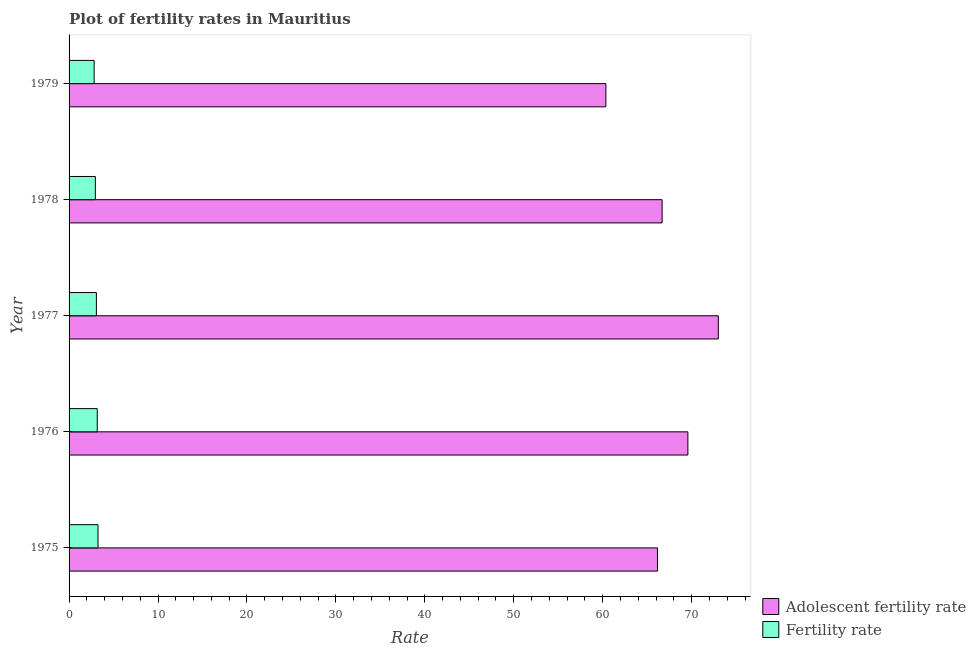How many bars are there on the 2nd tick from the bottom?
Keep it short and to the point. 2. What is the label of the 1st group of bars from the top?
Your answer should be compact. 1979. In how many cases, is the number of bars for a given year not equal to the number of legend labels?
Provide a succinct answer. 0. What is the adolescent fertility rate in 1977?
Your answer should be very brief. 73. Across all years, what is the maximum fertility rate?
Make the answer very short. 3.25. Across all years, what is the minimum fertility rate?
Offer a very short reply. 2.82. In which year was the fertility rate minimum?
Provide a succinct answer. 1979. What is the total adolescent fertility rate in the graph?
Keep it short and to the point. 335.78. What is the difference between the fertility rate in 1975 and that in 1979?
Make the answer very short. 0.44. What is the difference between the adolescent fertility rate in 1979 and the fertility rate in 1977?
Make the answer very short. 57.29. What is the average fertility rate per year?
Your response must be concise. 3.05. In the year 1976, what is the difference between the adolescent fertility rate and fertility rate?
Make the answer very short. 66.41. In how many years, is the fertility rate greater than 44 ?
Provide a short and direct response. 0. What is the ratio of the adolescent fertility rate in 1975 to that in 1977?
Your response must be concise. 0.91. What is the difference between the highest and the second highest adolescent fertility rate?
Keep it short and to the point. 3.42. What is the difference between the highest and the lowest fertility rate?
Give a very brief answer. 0.44. In how many years, is the fertility rate greater than the average fertility rate taken over all years?
Give a very brief answer. 3. What does the 1st bar from the top in 1978 represents?
Your answer should be very brief. Fertility rate. What does the 1st bar from the bottom in 1976 represents?
Give a very brief answer. Adolescent fertility rate. How many bars are there?
Provide a succinct answer. 10. What is the difference between two consecutive major ticks on the X-axis?
Give a very brief answer. 10. Are the values on the major ticks of X-axis written in scientific E-notation?
Your response must be concise. No. Does the graph contain any zero values?
Your answer should be very brief. No. Does the graph contain grids?
Your response must be concise. No. Where does the legend appear in the graph?
Ensure brevity in your answer.  Bottom right. What is the title of the graph?
Offer a very short reply. Plot of fertility rates in Mauritius. Does "Mobile cellular" appear as one of the legend labels in the graph?
Ensure brevity in your answer.  No. What is the label or title of the X-axis?
Your answer should be very brief. Rate. What is the Rate in Adolescent fertility rate in 1975?
Your answer should be compact. 66.16. What is the Rate of Fertility rate in 1975?
Offer a very short reply. 3.25. What is the Rate in Adolescent fertility rate in 1976?
Make the answer very short. 69.58. What is the Rate in Fertility rate in 1976?
Your response must be concise. 3.17. What is the Rate in Adolescent fertility rate in 1977?
Keep it short and to the point. 73. What is the Rate in Fertility rate in 1977?
Your answer should be very brief. 3.07. What is the Rate in Adolescent fertility rate in 1978?
Ensure brevity in your answer.  66.68. What is the Rate in Fertility rate in 1978?
Your response must be concise. 2.95. What is the Rate in Adolescent fertility rate in 1979?
Your answer should be very brief. 60.36. What is the Rate of Fertility rate in 1979?
Offer a very short reply. 2.82. Across all years, what is the maximum Rate of Adolescent fertility rate?
Offer a very short reply. 73. Across all years, what is the maximum Rate in Fertility rate?
Your response must be concise. 3.25. Across all years, what is the minimum Rate in Adolescent fertility rate?
Ensure brevity in your answer.  60.36. Across all years, what is the minimum Rate of Fertility rate?
Give a very brief answer. 2.82. What is the total Rate of Adolescent fertility rate in the graph?
Your answer should be very brief. 335.78. What is the total Rate of Fertility rate in the graph?
Your response must be concise. 15.27. What is the difference between the Rate in Adolescent fertility rate in 1975 and that in 1976?
Ensure brevity in your answer.  -3.42. What is the difference between the Rate of Fertility rate in 1975 and that in 1976?
Make the answer very short. 0.09. What is the difference between the Rate of Adolescent fertility rate in 1975 and that in 1977?
Provide a succinct answer. -6.84. What is the difference between the Rate in Fertility rate in 1975 and that in 1977?
Make the answer very short. 0.18. What is the difference between the Rate in Adolescent fertility rate in 1975 and that in 1978?
Provide a short and direct response. -0.52. What is the difference between the Rate in Fertility rate in 1975 and that in 1978?
Give a very brief answer. 0.3. What is the difference between the Rate in Adolescent fertility rate in 1975 and that in 1979?
Offer a terse response. 5.8. What is the difference between the Rate of Fertility rate in 1975 and that in 1979?
Your response must be concise. 0.44. What is the difference between the Rate in Adolescent fertility rate in 1976 and that in 1977?
Offer a terse response. -3.42. What is the difference between the Rate of Fertility rate in 1976 and that in 1977?
Give a very brief answer. 0.1. What is the difference between the Rate in Adolescent fertility rate in 1976 and that in 1978?
Keep it short and to the point. 2.9. What is the difference between the Rate of Fertility rate in 1976 and that in 1978?
Your answer should be very brief. 0.21. What is the difference between the Rate of Adolescent fertility rate in 1976 and that in 1979?
Make the answer very short. 9.22. What is the difference between the Rate in Fertility rate in 1976 and that in 1979?
Offer a terse response. 0.35. What is the difference between the Rate of Adolescent fertility rate in 1977 and that in 1978?
Offer a terse response. 6.32. What is the difference between the Rate of Fertility rate in 1977 and that in 1978?
Offer a terse response. 0.12. What is the difference between the Rate of Adolescent fertility rate in 1977 and that in 1979?
Offer a terse response. 12.64. What is the difference between the Rate in Fertility rate in 1977 and that in 1979?
Offer a terse response. 0.25. What is the difference between the Rate of Adolescent fertility rate in 1978 and that in 1979?
Make the answer very short. 6.32. What is the difference between the Rate in Fertility rate in 1978 and that in 1979?
Ensure brevity in your answer.  0.14. What is the difference between the Rate in Adolescent fertility rate in 1975 and the Rate in Fertility rate in 1976?
Your response must be concise. 62.99. What is the difference between the Rate in Adolescent fertility rate in 1975 and the Rate in Fertility rate in 1977?
Your response must be concise. 63.09. What is the difference between the Rate in Adolescent fertility rate in 1975 and the Rate in Fertility rate in 1978?
Ensure brevity in your answer.  63.21. What is the difference between the Rate of Adolescent fertility rate in 1975 and the Rate of Fertility rate in 1979?
Your answer should be very brief. 63.34. What is the difference between the Rate of Adolescent fertility rate in 1976 and the Rate of Fertility rate in 1977?
Your answer should be compact. 66.51. What is the difference between the Rate in Adolescent fertility rate in 1976 and the Rate in Fertility rate in 1978?
Make the answer very short. 66.63. What is the difference between the Rate of Adolescent fertility rate in 1976 and the Rate of Fertility rate in 1979?
Your answer should be compact. 66.76. What is the difference between the Rate in Adolescent fertility rate in 1977 and the Rate in Fertility rate in 1978?
Keep it short and to the point. 70.05. What is the difference between the Rate in Adolescent fertility rate in 1977 and the Rate in Fertility rate in 1979?
Keep it short and to the point. 70.18. What is the difference between the Rate of Adolescent fertility rate in 1978 and the Rate of Fertility rate in 1979?
Make the answer very short. 63.86. What is the average Rate of Adolescent fertility rate per year?
Offer a very short reply. 67.16. What is the average Rate of Fertility rate per year?
Make the answer very short. 3.05. In the year 1975, what is the difference between the Rate in Adolescent fertility rate and Rate in Fertility rate?
Make the answer very short. 62.9. In the year 1976, what is the difference between the Rate of Adolescent fertility rate and Rate of Fertility rate?
Your answer should be compact. 66.41. In the year 1977, what is the difference between the Rate of Adolescent fertility rate and Rate of Fertility rate?
Your answer should be compact. 69.93. In the year 1978, what is the difference between the Rate of Adolescent fertility rate and Rate of Fertility rate?
Your answer should be very brief. 63.73. In the year 1979, what is the difference between the Rate of Adolescent fertility rate and Rate of Fertility rate?
Offer a very short reply. 57.54. What is the ratio of the Rate in Adolescent fertility rate in 1975 to that in 1976?
Provide a succinct answer. 0.95. What is the ratio of the Rate of Fertility rate in 1975 to that in 1976?
Provide a short and direct response. 1.03. What is the ratio of the Rate of Adolescent fertility rate in 1975 to that in 1977?
Keep it short and to the point. 0.91. What is the ratio of the Rate in Fertility rate in 1975 to that in 1977?
Offer a very short reply. 1.06. What is the ratio of the Rate of Fertility rate in 1975 to that in 1978?
Offer a terse response. 1.1. What is the ratio of the Rate in Adolescent fertility rate in 1975 to that in 1979?
Your answer should be very brief. 1.1. What is the ratio of the Rate of Fertility rate in 1975 to that in 1979?
Offer a terse response. 1.16. What is the ratio of the Rate in Adolescent fertility rate in 1976 to that in 1977?
Make the answer very short. 0.95. What is the ratio of the Rate of Fertility rate in 1976 to that in 1977?
Offer a very short reply. 1.03. What is the ratio of the Rate of Adolescent fertility rate in 1976 to that in 1978?
Ensure brevity in your answer.  1.04. What is the ratio of the Rate in Fertility rate in 1976 to that in 1978?
Your response must be concise. 1.07. What is the ratio of the Rate of Adolescent fertility rate in 1976 to that in 1979?
Your response must be concise. 1.15. What is the ratio of the Rate in Fertility rate in 1976 to that in 1979?
Offer a terse response. 1.12. What is the ratio of the Rate of Adolescent fertility rate in 1977 to that in 1978?
Make the answer very short. 1.09. What is the ratio of the Rate of Fertility rate in 1977 to that in 1978?
Provide a short and direct response. 1.04. What is the ratio of the Rate of Adolescent fertility rate in 1977 to that in 1979?
Offer a very short reply. 1.21. What is the ratio of the Rate of Fertility rate in 1977 to that in 1979?
Your answer should be very brief. 1.09. What is the ratio of the Rate of Adolescent fertility rate in 1978 to that in 1979?
Your answer should be very brief. 1.1. What is the ratio of the Rate of Fertility rate in 1978 to that in 1979?
Provide a succinct answer. 1.05. What is the difference between the highest and the second highest Rate of Adolescent fertility rate?
Offer a terse response. 3.42. What is the difference between the highest and the second highest Rate of Fertility rate?
Offer a terse response. 0.09. What is the difference between the highest and the lowest Rate in Adolescent fertility rate?
Ensure brevity in your answer.  12.64. What is the difference between the highest and the lowest Rate of Fertility rate?
Your response must be concise. 0.44. 